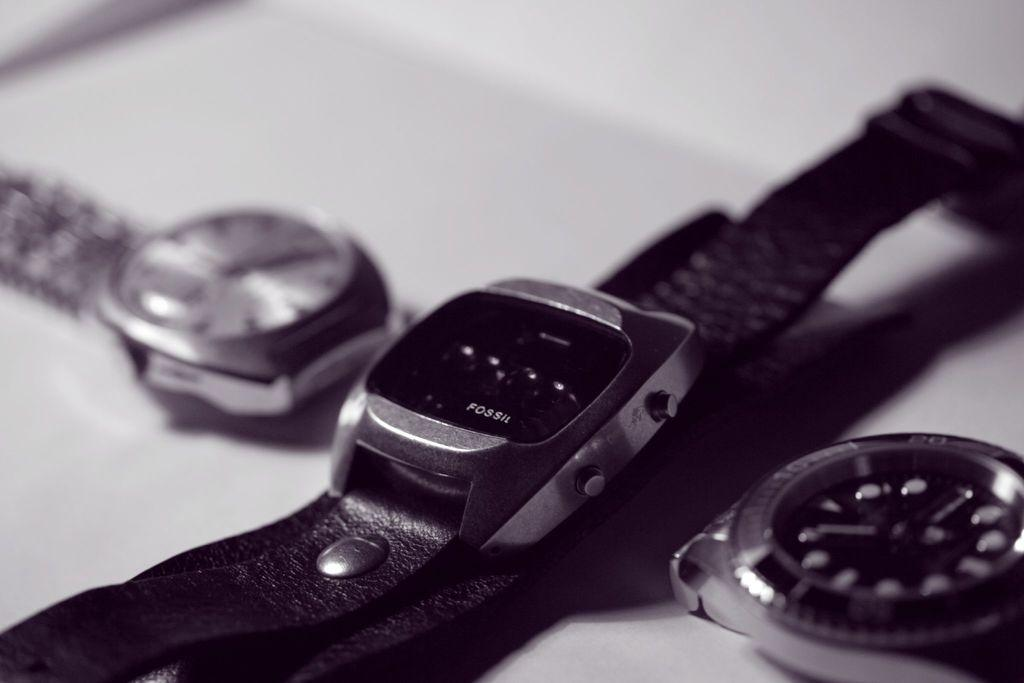<image>
Give a short and clear explanation of the subsequent image. Three watches sitting on a cloth, one with writing Fossil on it. 